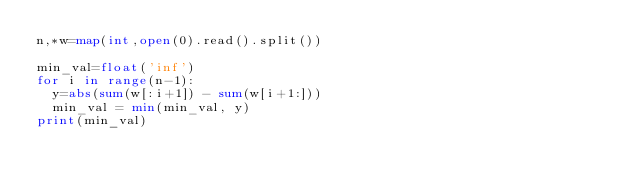Convert code to text. <code><loc_0><loc_0><loc_500><loc_500><_Python_>n,*w=map(int,open(0).read().split())

min_val=float('inf')
for i in range(n-1):
  y=abs(sum(w[:i+1]) - sum(w[i+1:]))
  min_val = min(min_val, y)
print(min_val)</code> 